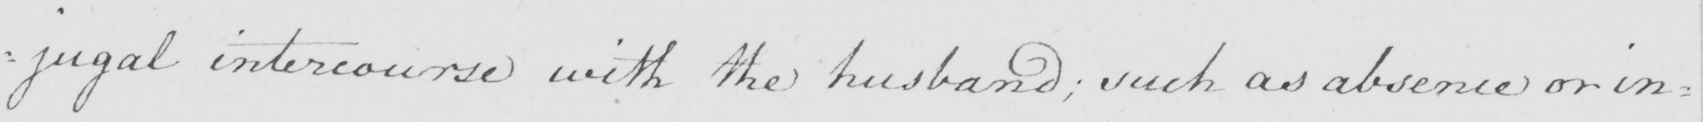What does this handwritten line say? : jugal intercourse with the husband ; such an absence or in= 